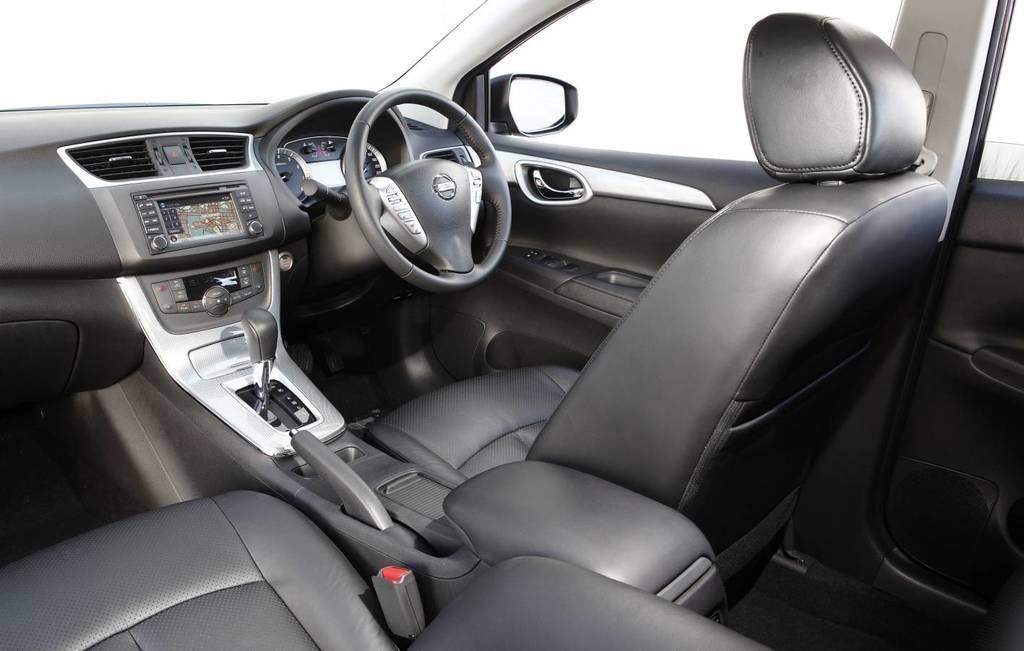Could you give a brief overview of what you see in this image? In this picture we can see a steering, gear, display, speedometer, seats, side mirror and some parts of a vehicle. 